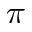Convert formula to latex. <formula><loc_0><loc_0><loc_500><loc_500>\pi</formula> 